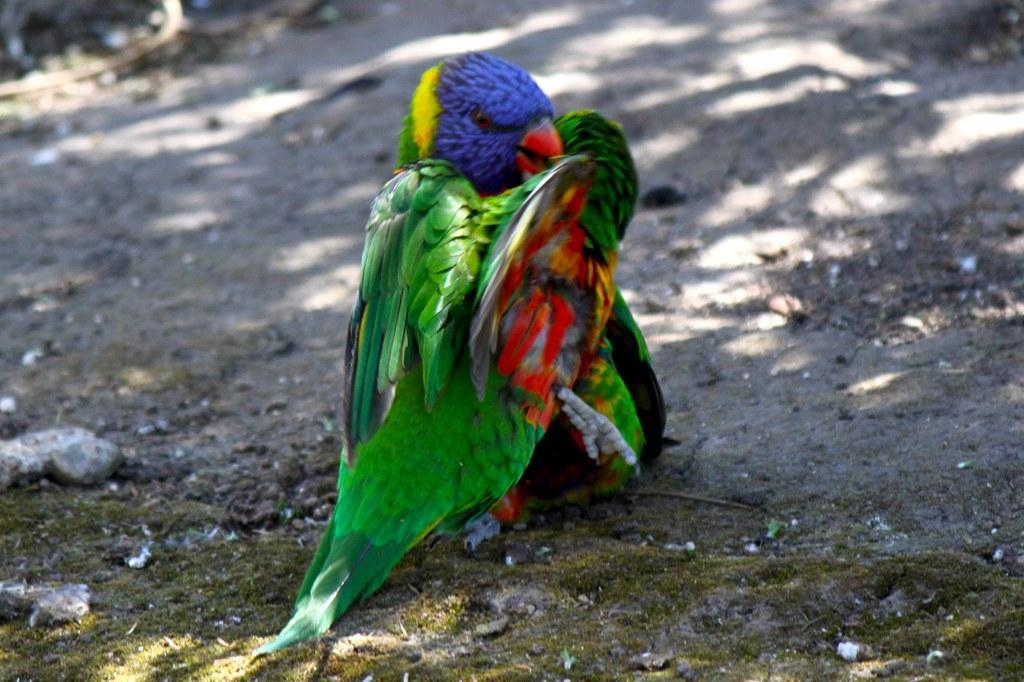How many parrots are in the image? There are two parrots in the image. What can be observed about the appearance of the parrots? The parrots are in different colors. Where are the parrots located in the image? The parrots are standing on the ground. What type of apparatus is being used by the parrots in the image? There is no apparatus present in the image; the parrots are simply standing on the ground. Is there a lamp visible in the image? No, there is no lamp present in the image. 